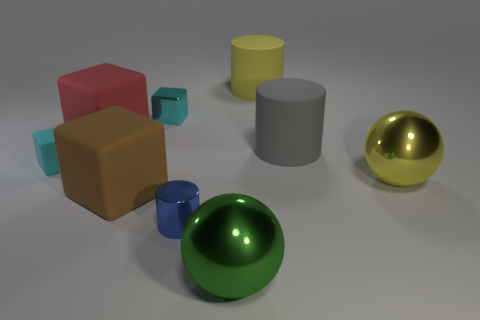Subtract 1 cubes. How many cubes are left? 3 Add 1 tiny metal cylinders. How many objects exist? 10 Subtract all cubes. How many objects are left? 5 Subtract all small purple rubber cylinders. Subtract all large yellow matte cylinders. How many objects are left? 8 Add 7 yellow things. How many yellow things are left? 9 Add 1 small purple shiny cylinders. How many small purple shiny cylinders exist? 1 Subtract 1 blue cylinders. How many objects are left? 8 